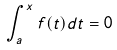Convert formula to latex. <formula><loc_0><loc_0><loc_500><loc_500>\int _ { a } ^ { x } f ( t ) d t = 0</formula> 